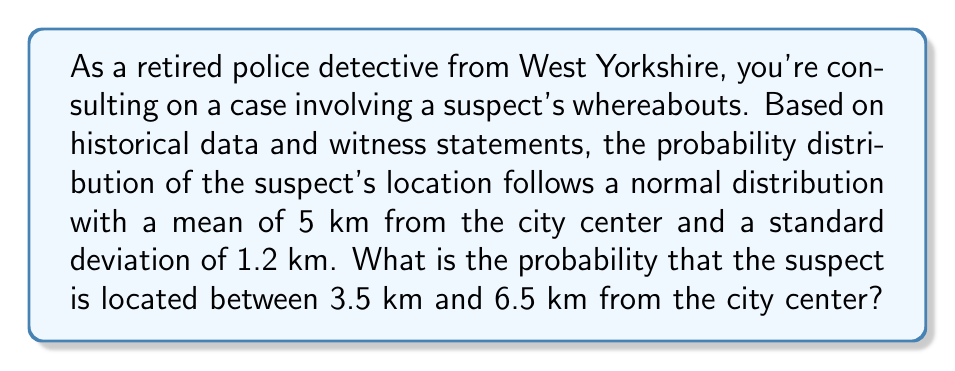What is the answer to this math problem? To solve this problem, we need to use the properties of the normal distribution and the concept of z-scores. Let's break it down step-by-step:

1) We're given that the location follows a normal distribution with:
   $\mu = 5$ km (mean)
   $\sigma = 1.2$ km (standard deviation)

2) We want to find the probability that the suspect is between 3.5 km and 6.5 km from the city center.

3) To use the standard normal distribution table, we need to convert these values to z-scores:

   For 3.5 km: $z_1 = \frac{3.5 - 5}{1.2} = -1.25$
   For 6.5 km: $z_2 = \frac{6.5 - 5}{1.2} = 1.25$

4) Now, we need to find $P(-1.25 < Z < 1.25)$

5) This can be rewritten as:
   $P(-1.25 < Z < 1.25) = P(Z < 1.25) - P(Z < -1.25)$

6) Using a standard normal distribution table or calculator:
   $P(Z < 1.25) \approx 0.8944$
   $P(Z < -1.25) \approx 0.1056$

7) Therefore:
   $P(-1.25 < Z < 1.25) = 0.8944 - 0.1056 = 0.7888$

8) Convert to a percentage: $0.7888 \times 100\% = 78.88\%$
Answer: The probability that the suspect is located between 3.5 km and 6.5 km from the city center is approximately 78.88%. 